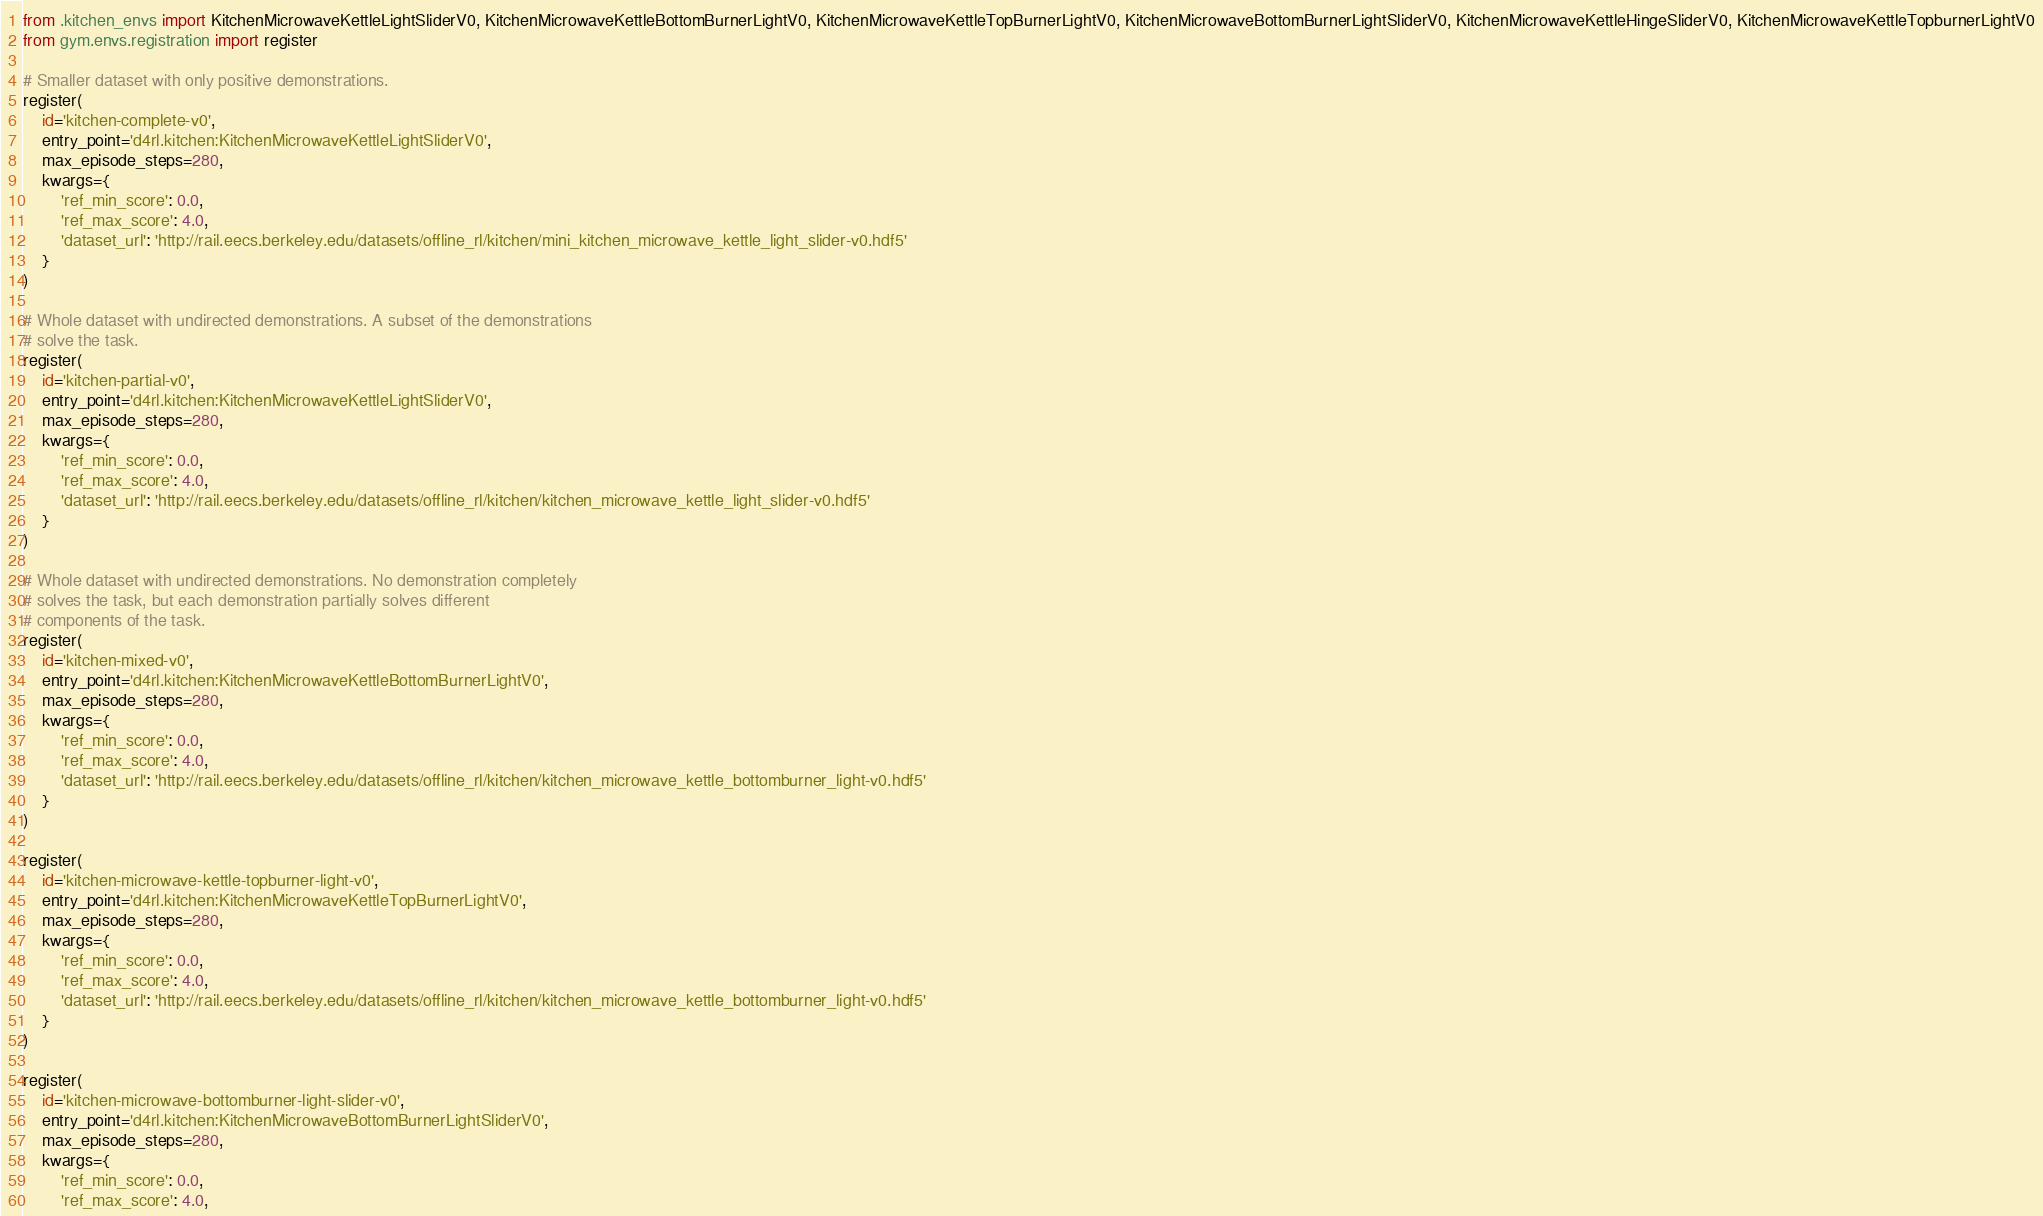Convert code to text. <code><loc_0><loc_0><loc_500><loc_500><_Python_>from .kitchen_envs import KitchenMicrowaveKettleLightSliderV0, KitchenMicrowaveKettleBottomBurnerLightV0, KitchenMicrowaveKettleTopBurnerLightV0, KitchenMicrowaveBottomBurnerLightSliderV0, KitchenMicrowaveKettleHingeSliderV0, KitchenMicrowaveKettleTopburnerLightV0
from gym.envs.registration import register

# Smaller dataset with only positive demonstrations.
register(
    id='kitchen-complete-v0',
    entry_point='d4rl.kitchen:KitchenMicrowaveKettleLightSliderV0',
    max_episode_steps=280,
    kwargs={
        'ref_min_score': 0.0,
        'ref_max_score': 4.0,
        'dataset_url': 'http://rail.eecs.berkeley.edu/datasets/offline_rl/kitchen/mini_kitchen_microwave_kettle_light_slider-v0.hdf5'
    }
)

# Whole dataset with undirected demonstrations. A subset of the demonstrations
# solve the task.
register(
    id='kitchen-partial-v0',
    entry_point='d4rl.kitchen:KitchenMicrowaveKettleLightSliderV0',
    max_episode_steps=280,
    kwargs={
        'ref_min_score': 0.0,
        'ref_max_score': 4.0,
        'dataset_url': 'http://rail.eecs.berkeley.edu/datasets/offline_rl/kitchen/kitchen_microwave_kettle_light_slider-v0.hdf5'
    }
)

# Whole dataset with undirected demonstrations. No demonstration completely
# solves the task, but each demonstration partially solves different
# components of the task.
register(
    id='kitchen-mixed-v0',
    entry_point='d4rl.kitchen:KitchenMicrowaveKettleBottomBurnerLightV0',
    max_episode_steps=280,
    kwargs={
        'ref_min_score': 0.0,
        'ref_max_score': 4.0,
        'dataset_url': 'http://rail.eecs.berkeley.edu/datasets/offline_rl/kitchen/kitchen_microwave_kettle_bottomburner_light-v0.hdf5'
    }
)

register(
    id='kitchen-microwave-kettle-topburner-light-v0',
    entry_point='d4rl.kitchen:KitchenMicrowaveKettleTopBurnerLightV0',
    max_episode_steps=280,
    kwargs={
        'ref_min_score': 0.0,
        'ref_max_score': 4.0,
        'dataset_url': 'http://rail.eecs.berkeley.edu/datasets/offline_rl/kitchen/kitchen_microwave_kettle_bottomburner_light-v0.hdf5'
    }
)

register(
    id='kitchen-microwave-bottomburner-light-slider-v0',
    entry_point='d4rl.kitchen:KitchenMicrowaveBottomBurnerLightSliderV0',
    max_episode_steps=280,
    kwargs={
        'ref_min_score': 0.0,
        'ref_max_score': 4.0,</code> 